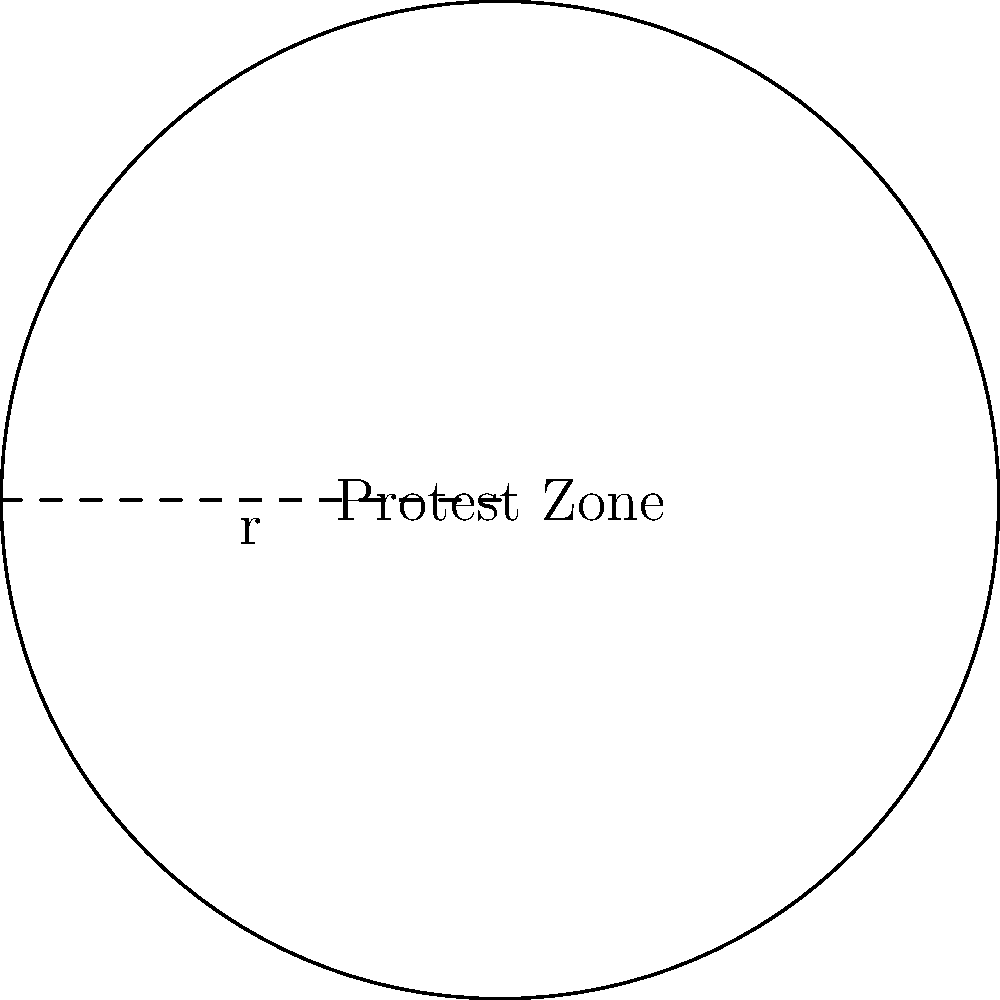As a youth leader organizing a peaceful protest, you've been granted a circular area in the city center with a radius of 30 meters for your demonstration. If each protester requires 4 square meters of space to comply with social distancing guidelines, what is the maximum number of protesters that can safely fit within the designated protest zone? Let's approach this step-by-step:

1) First, we need to calculate the area of the circular protest zone.
   The formula for the area of a circle is $A = \pi r^2$

2) We're given that the radius (r) is 30 meters.
   So, $A = \pi (30)^2 = 900\pi$ square meters

3) Now, we know that each protester requires 4 square meters of space.
   To find the number of protesters, we need to divide the total area by the space each protester needs.

4) Number of protesters = Total area / Space per protester
   $N = \frac{900\pi}{4}$

5) Simplifying:
   $N = 225\pi$

6) Since we can't have a fractional number of protesters, we need to round down to the nearest whole number.

7) $225\pi \approx 706.86$

Therefore, the maximum number of protesters that can safely fit is 706.
Answer: 706 protesters 